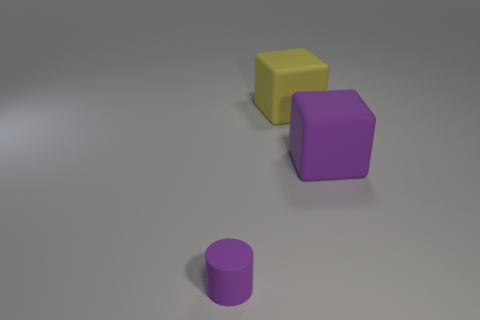Is there anything else that is the same size as the purple cylinder?
Your response must be concise. No. What number of things are green metal things or purple objects behind the cylinder?
Offer a very short reply. 1. There is a matte thing that is the same size as the yellow block; what shape is it?
Offer a terse response. Cube. What number of matte blocks are the same color as the small cylinder?
Provide a succinct answer. 1. The tiny object is what shape?
Offer a terse response. Cylinder. What number of brown things are blocks or tiny matte cylinders?
Provide a short and direct response. 0. Does the large object that is on the right side of the big yellow cube have the same shape as the large yellow thing?
Your answer should be compact. Yes. Are there any big yellow rubber balls?
Your answer should be very brief. No. Is there any other thing that has the same shape as the tiny rubber thing?
Offer a very short reply. No. Is the number of small cylinders that are on the left side of the cylinder greater than the number of large purple rubber objects?
Keep it short and to the point. No. 